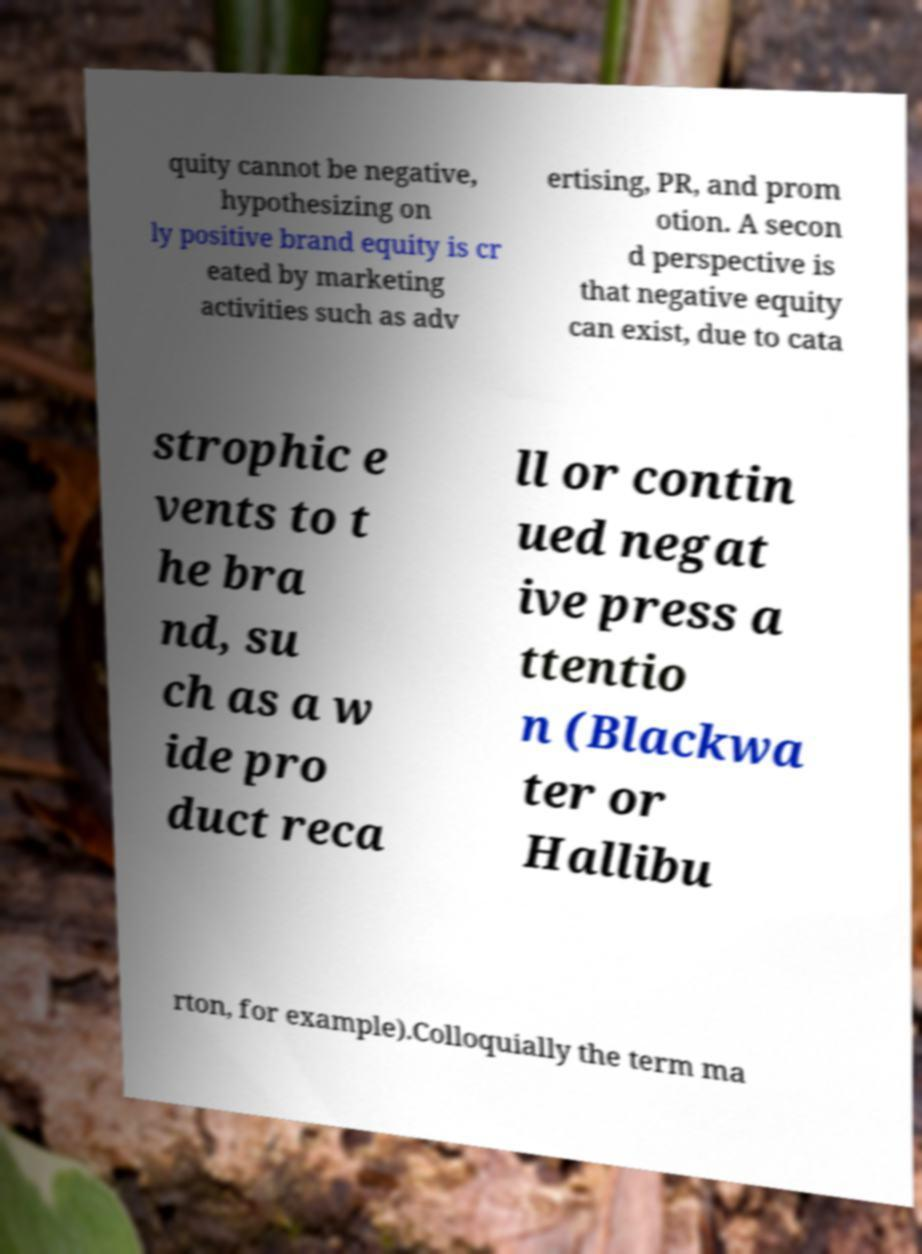Could you extract and type out the text from this image? quity cannot be negative, hypothesizing on ly positive brand equity is cr eated by marketing activities such as adv ertising, PR, and prom otion. A secon d perspective is that negative equity can exist, due to cata strophic e vents to t he bra nd, su ch as a w ide pro duct reca ll or contin ued negat ive press a ttentio n (Blackwa ter or Hallibu rton, for example).Colloquially the term ma 